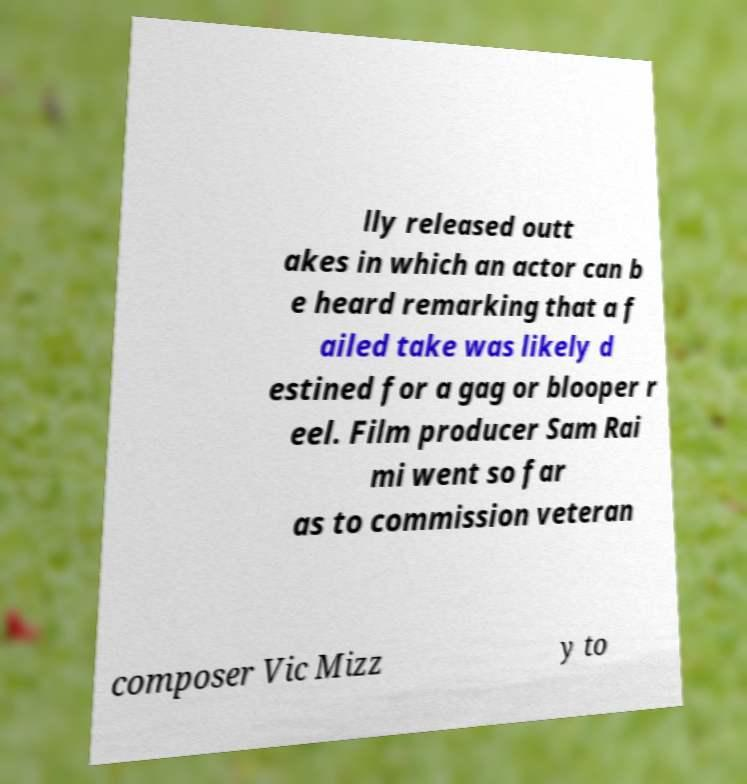Can you accurately transcribe the text from the provided image for me? lly released outt akes in which an actor can b e heard remarking that a f ailed take was likely d estined for a gag or blooper r eel. Film producer Sam Rai mi went so far as to commission veteran composer Vic Mizz y to 